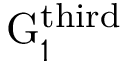<formula> <loc_0><loc_0><loc_500><loc_500>G _ { 1 } ^ { t h i r d }</formula> 